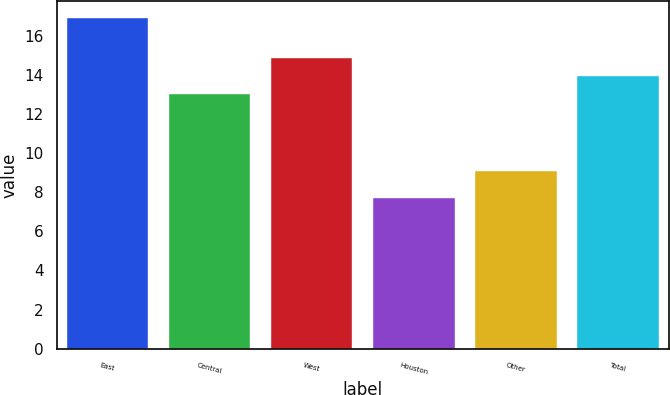Convert chart. <chart><loc_0><loc_0><loc_500><loc_500><bar_chart><fcel>East<fcel>Central<fcel>West<fcel>Houston<fcel>Other<fcel>Total<nl><fcel>16.9<fcel>13<fcel>14.84<fcel>7.7<fcel>9.1<fcel>13.92<nl></chart> 